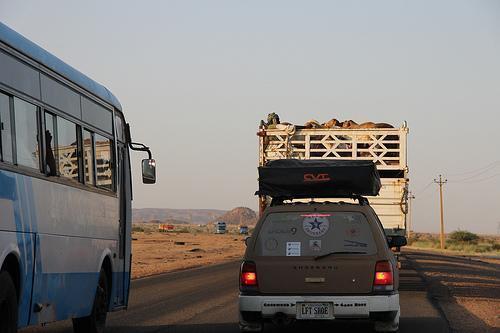How many busses are visible?
Give a very brief answer. 1. 